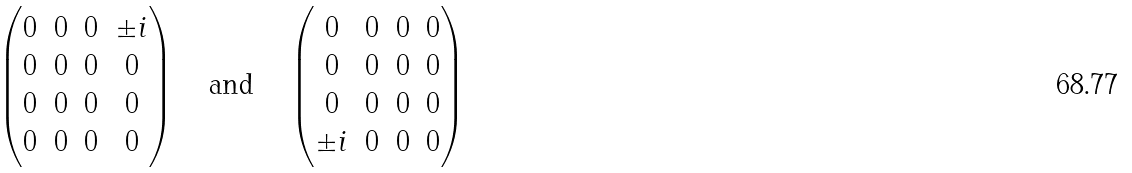<formula> <loc_0><loc_0><loc_500><loc_500>\begin{pmatrix} 0 & 0 & 0 & \pm i \\ 0 & 0 & 0 & 0 \\ 0 & 0 & 0 & 0 \\ 0 & 0 & 0 & 0 \end{pmatrix} \quad \text {and} \quad \begin{pmatrix} 0 & 0 & 0 & 0 \\ 0 & 0 & 0 & 0 \\ 0 & 0 & 0 & 0 \\ \pm i & 0 & 0 & 0 \end{pmatrix}</formula> 